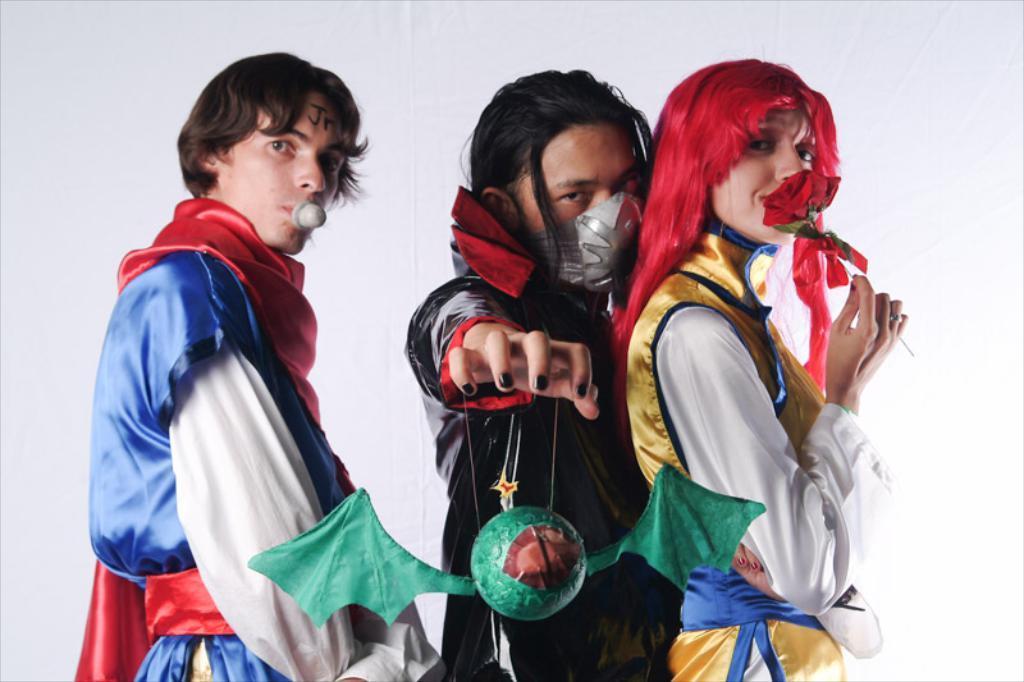Describe this image in one or two sentences. In this image we can see persons with costumes standing on the floor. In the background there is wall. 